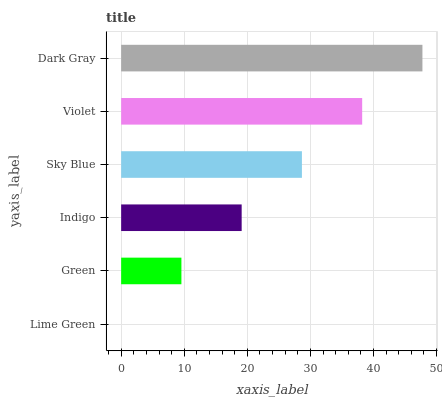Is Lime Green the minimum?
Answer yes or no. Yes. Is Dark Gray the maximum?
Answer yes or no. Yes. Is Green the minimum?
Answer yes or no. No. Is Green the maximum?
Answer yes or no. No. Is Green greater than Lime Green?
Answer yes or no. Yes. Is Lime Green less than Green?
Answer yes or no. Yes. Is Lime Green greater than Green?
Answer yes or no. No. Is Green less than Lime Green?
Answer yes or no. No. Is Sky Blue the high median?
Answer yes or no. Yes. Is Indigo the low median?
Answer yes or no. Yes. Is Violet the high median?
Answer yes or no. No. Is Lime Green the low median?
Answer yes or no. No. 